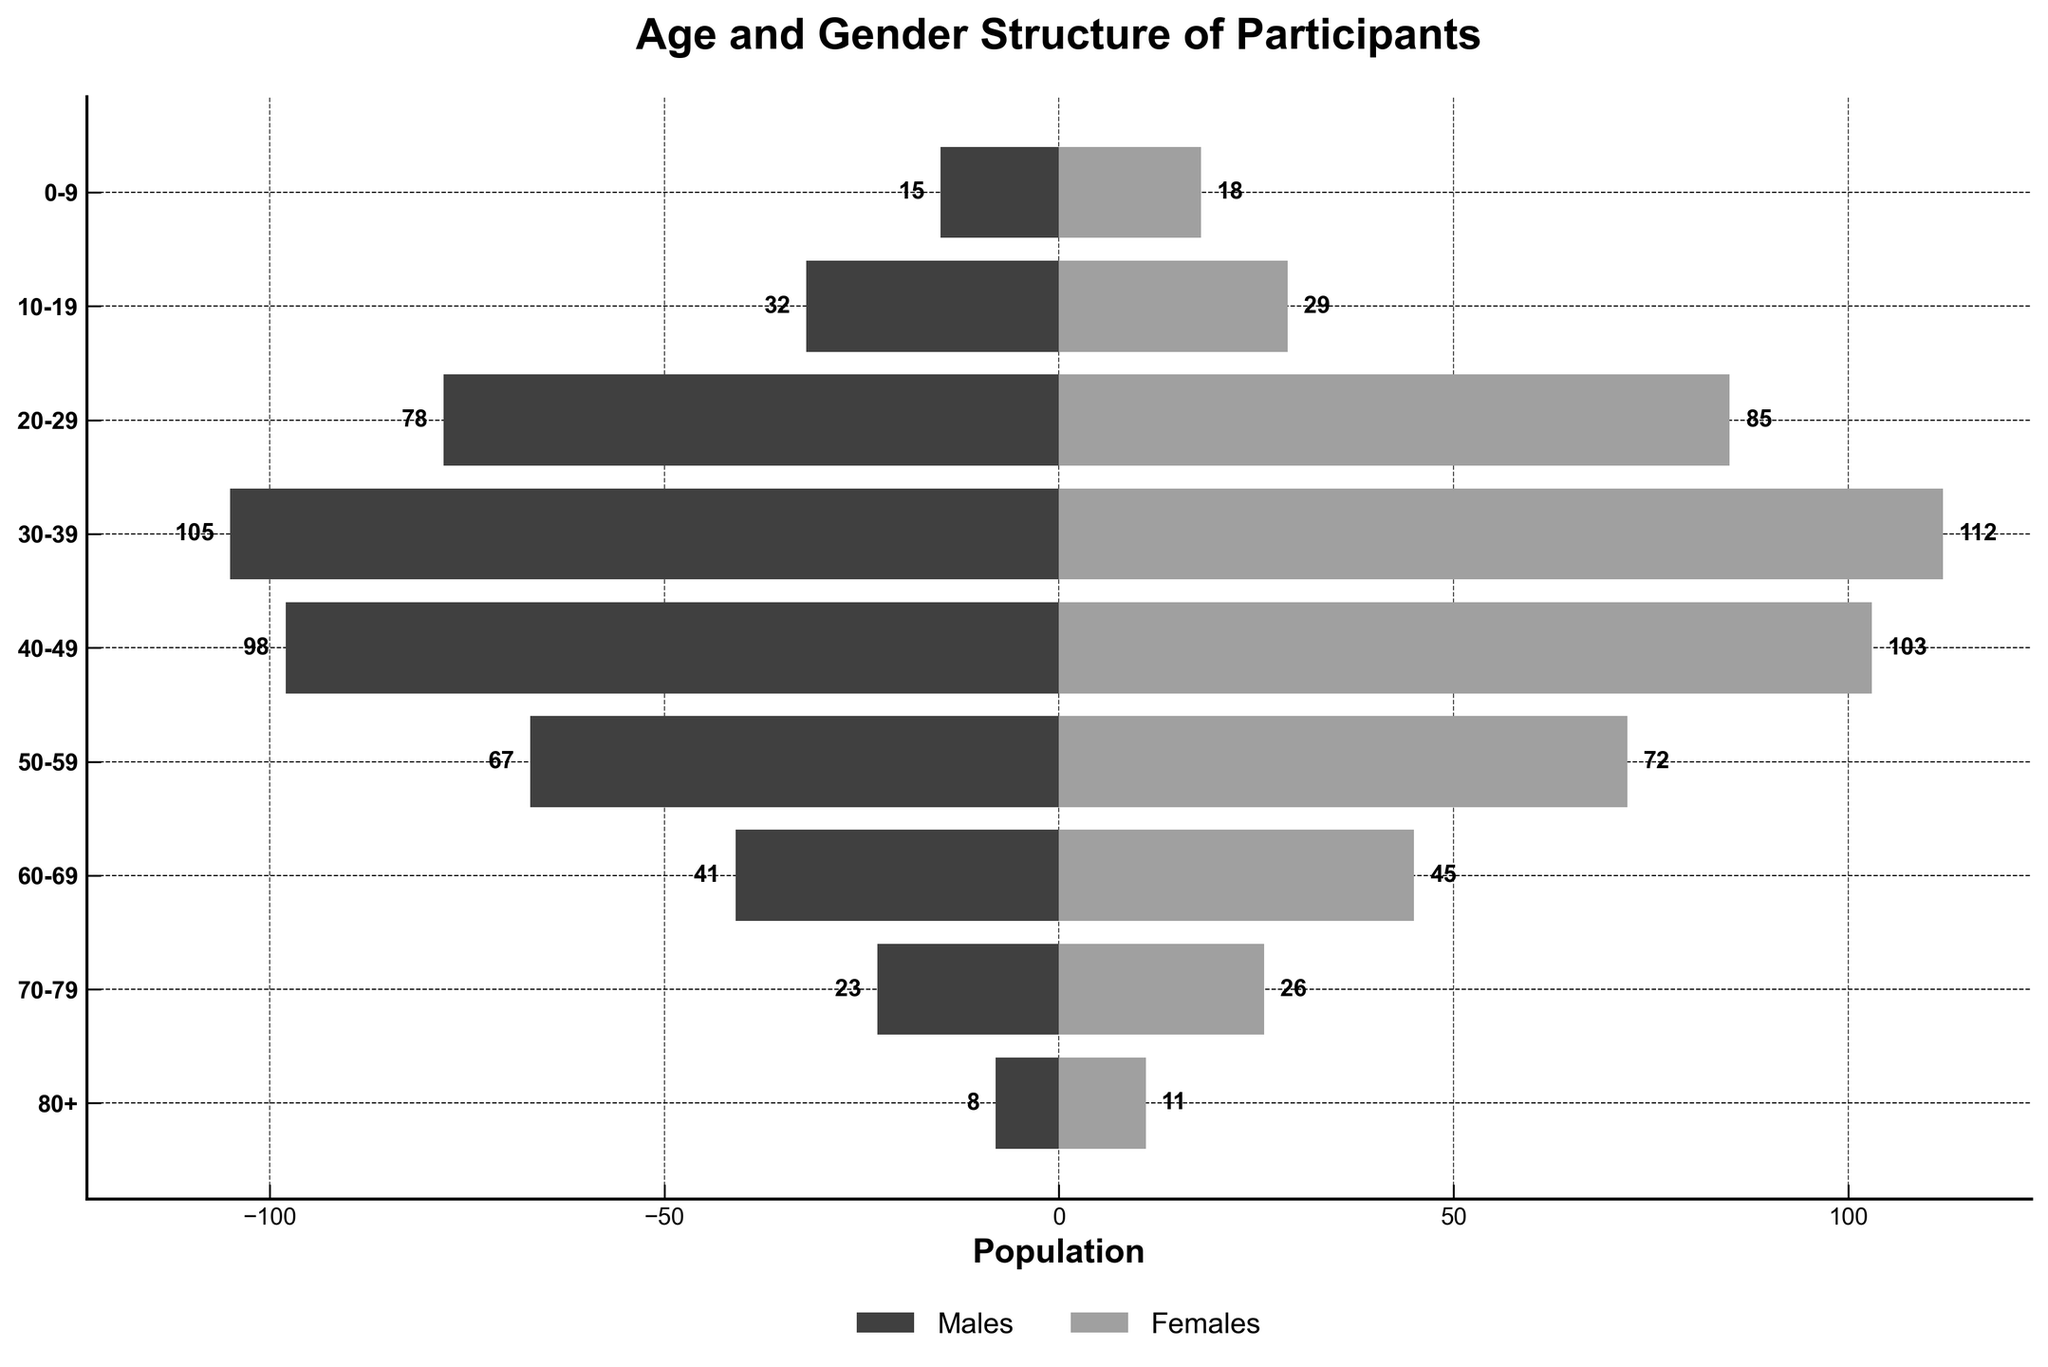what is the title of the figure? The title of the figure is located at the top center of the chart. It is displayed in bold font and serves to summarize the main focus of the figure.
Answer: Age and Gender Structure of Participants how many age groups are shown in the figure? The figure displays age groups along the vertical axis, and each group corresponds to a tick mark with a label. By counting these tick marks, we can determine the number of age groups.
Answer: 9 which gender has more participants in the 30-39 age group? To determine which gender has more participants, compare the length of the bars for Males and Females within the 30-39 age group on the chart.
Answer: Females what is the highest number of participants in any age group? To determine this, find the maximum value of the population counts displayed next to the bars for any age group.
Answer: 112 what is the combined number of participants in the 0-9 and 80+ age groups? Sum up the number of Males and Females from both the 0-9 and 80+ age groups. For 0-9: 15 (Males) + 18 (Females); for 80+: 8 (Males) + 11 (Females).
Answer: 52 which age group has the smallest gender difference in the number of participants? To find this, look at the absolute differences between the number of Males and Females for each age group and identify which has the smallest difference.
Answer: 60-69 which age group has more males than females? Identify the age groups where the bar for Males is longer than the bar for Females.
Answer: 10-19 which age group has the largest number of female participants? Determine which age group has the longest bar for Females.
Answer: 30-39 